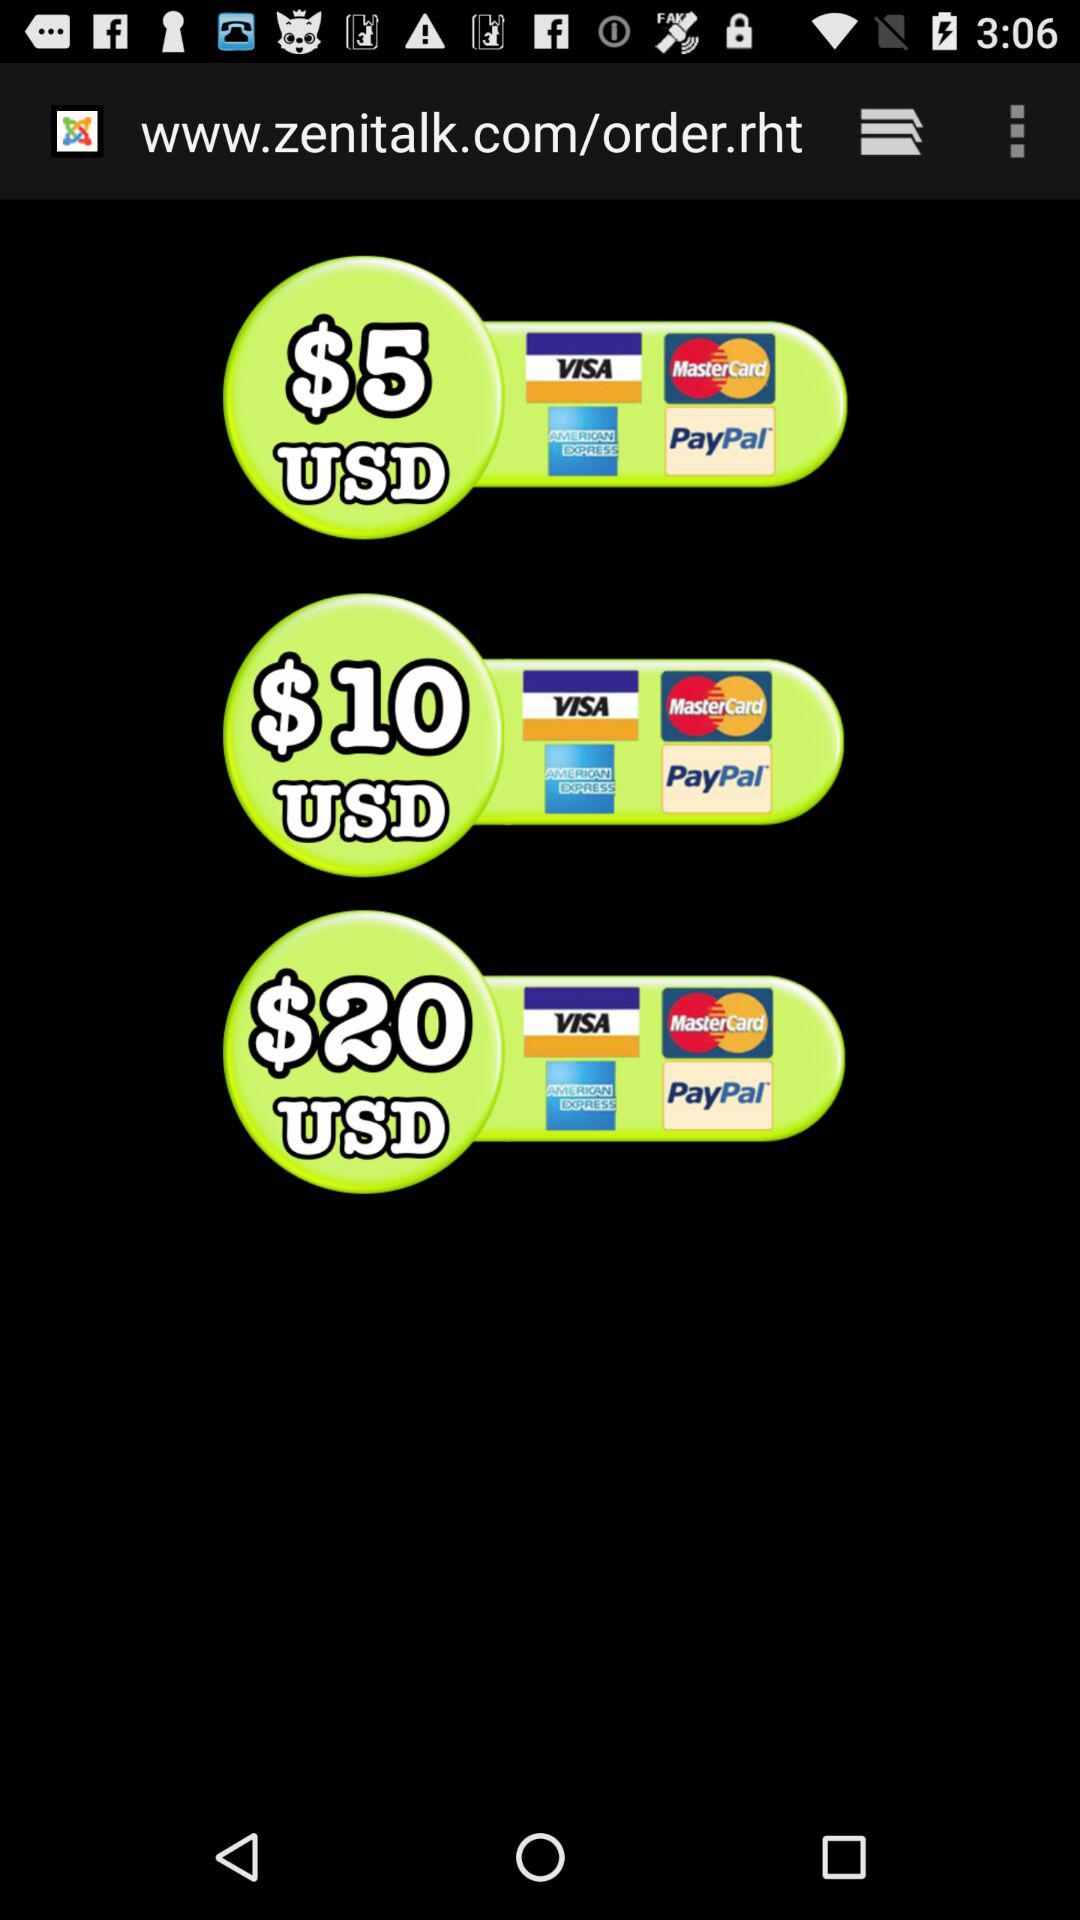How much more is the price of the $20 USD credit card than the $10 USD credit card?
Answer the question using a single word or phrase. 10 